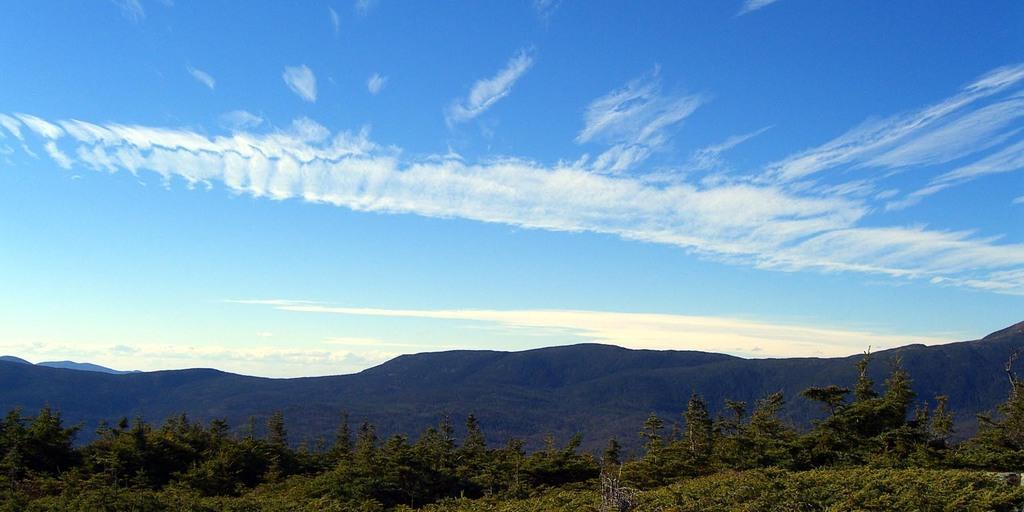Could you give a brief overview of what you see in this image? In this image there are some trees in bottom of this image and there are some mountains in the background and there is a cloudy sky at top of this image. 